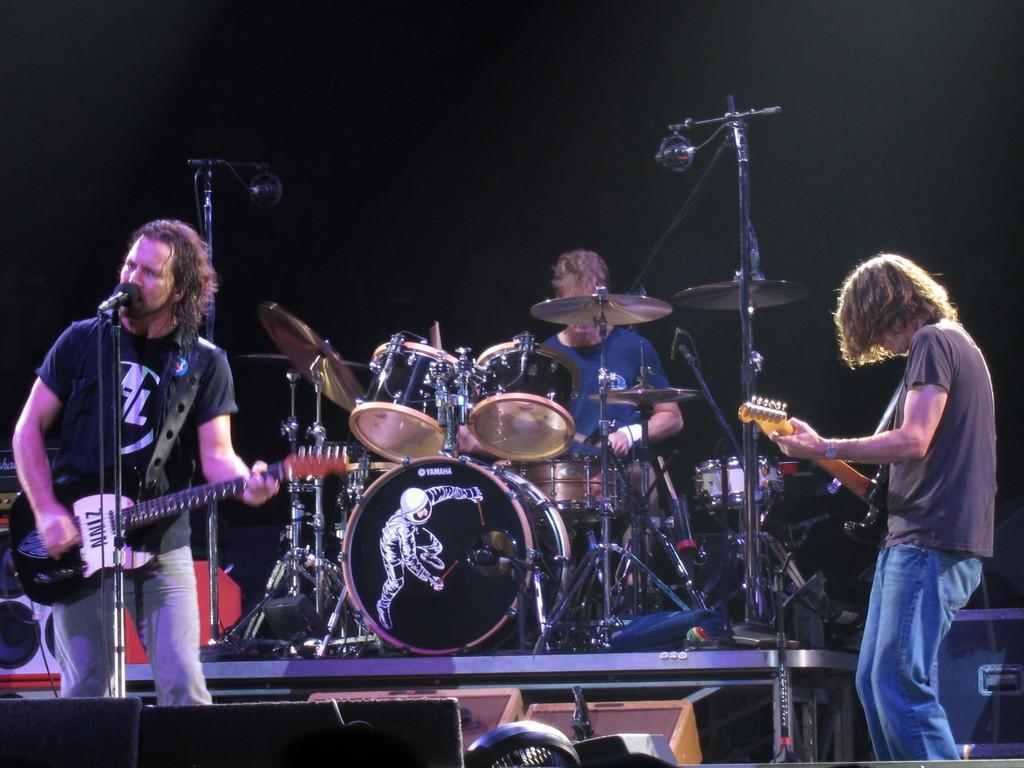Describe this image in one or two sentences. There are three people standing and playing musical instruments. On the left hand side, the person is holding a guitar and singing. In the background, there are drums. And background is in dark color. 